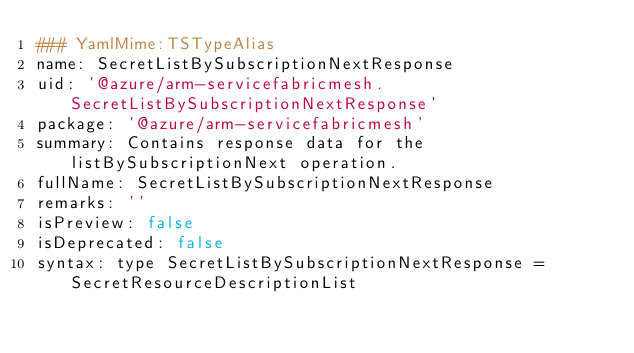Convert code to text. <code><loc_0><loc_0><loc_500><loc_500><_YAML_>### YamlMime:TSTypeAlias
name: SecretListBySubscriptionNextResponse
uid: '@azure/arm-servicefabricmesh.SecretListBySubscriptionNextResponse'
package: '@azure/arm-servicefabricmesh'
summary: Contains response data for the listBySubscriptionNext operation.
fullName: SecretListBySubscriptionNextResponse
remarks: ''
isPreview: false
isDeprecated: false
syntax: type SecretListBySubscriptionNextResponse = SecretResourceDescriptionList
</code> 